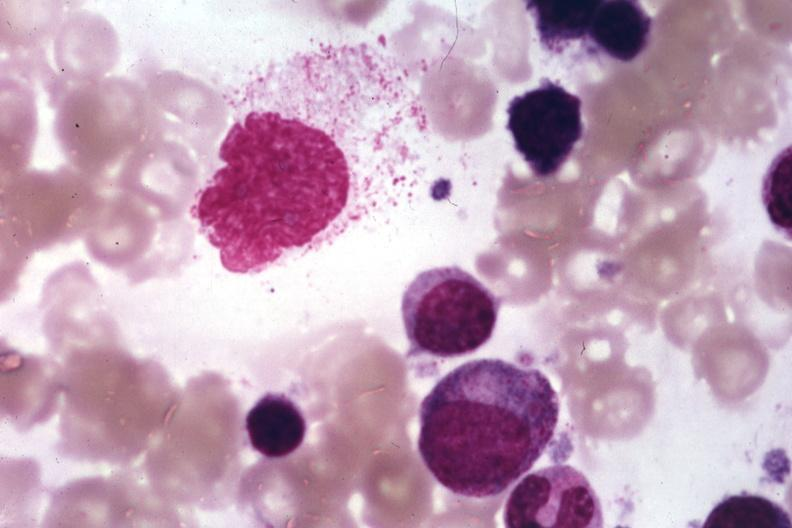s histiocyte present?
Answer the question using a single word or phrase. Yes 